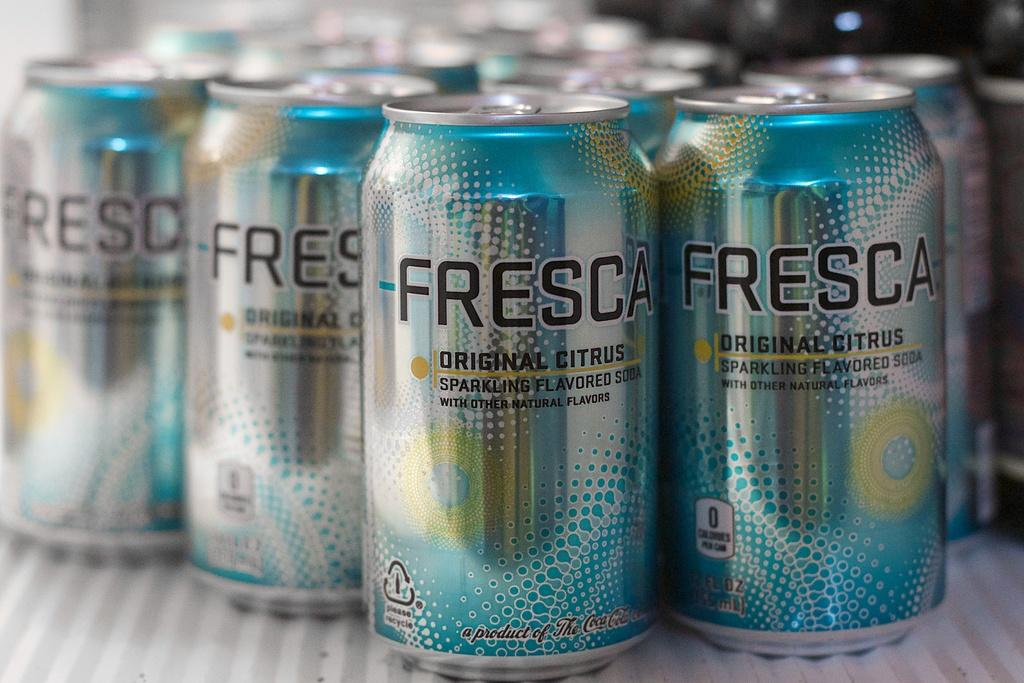<image>
Create a compact narrative representing the image presented. Many cans of Fresca soda sitting on a white shelf. 